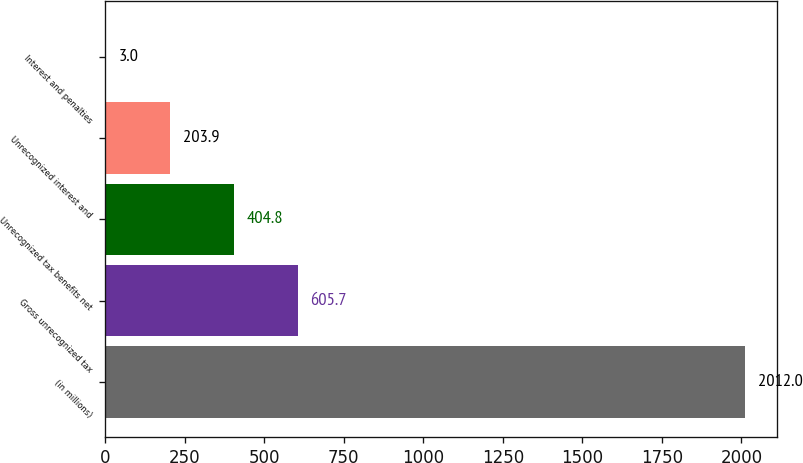<chart> <loc_0><loc_0><loc_500><loc_500><bar_chart><fcel>(in millions)<fcel>Gross unrecognized tax<fcel>Unrecognized tax benefits net<fcel>Unrecognized interest and<fcel>Interest and penalties<nl><fcel>2012<fcel>605.7<fcel>404.8<fcel>203.9<fcel>3<nl></chart> 